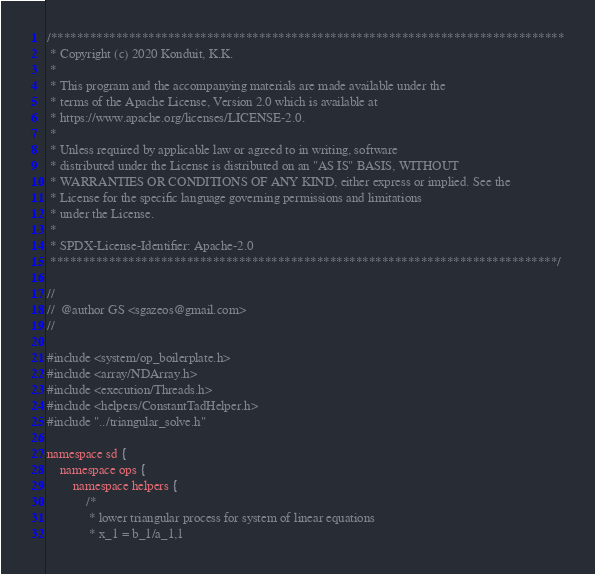<code> <loc_0><loc_0><loc_500><loc_500><_Cuda_>/*******************************************************************************
 * Copyright (c) 2020 Konduit, K.K.
 *
 * This program and the accompanying materials are made available under the
 * terms of the Apache License, Version 2.0 which is available at
 * https://www.apache.org/licenses/LICENSE-2.0.
 *
 * Unless required by applicable law or agreed to in writing, software
 * distributed under the License is distributed on an "AS IS" BASIS, WITHOUT
 * WARRANTIES OR CONDITIONS OF ANY KIND, either express or implied. See the
 * License for the specific language governing permissions and limitations
 * under the License.
 *
 * SPDX-License-Identifier: Apache-2.0
 ******************************************************************************/

//
//  @author GS <sgazeos@gmail.com>
//

#include <system/op_boilerplate.h>
#include <array/NDArray.h>
#include <execution/Threads.h>
#include <helpers/ConstantTadHelper.h>
#include "../triangular_solve.h"

namespace sd {
    namespace ops {
        namespace helpers {
            /*
             * lower triangular process for system of linear equations
             * x_1 = b_1/a_1,1</code> 